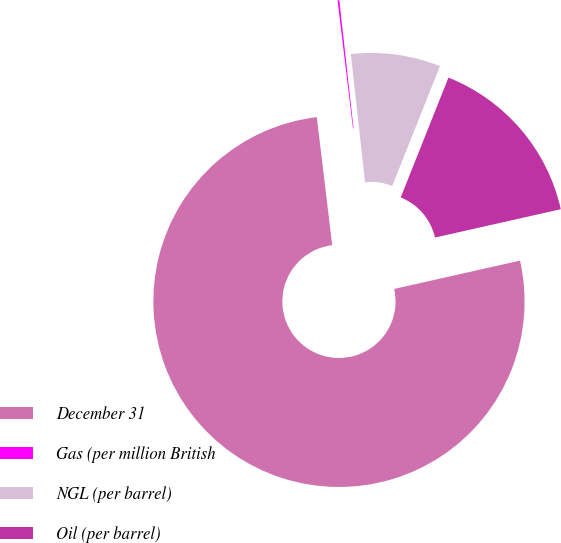Convert chart. <chart><loc_0><loc_0><loc_500><loc_500><pie_chart><fcel>December 31<fcel>Gas (per million British<fcel>NGL (per barrel)<fcel>Oil (per barrel)<nl><fcel>76.62%<fcel>0.15%<fcel>7.79%<fcel>15.44%<nl></chart> 